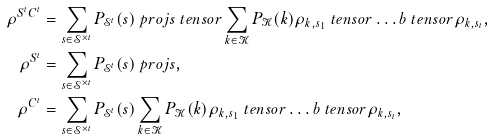<formula> <loc_0><loc_0><loc_500><loc_500>\rho ^ { S ^ { t } C ^ { t } } & = \sum _ { s \in \mathcal { S } ^ { \times t } } P _ { \mathcal { S } ^ { t } } ( s ) \ p r o j { s } \ t e n s o r \sum _ { k \in \mathcal { K } } P _ { \mathcal { K } } ( k ) \rho _ { k , s _ { 1 } } \ t e n s o r \dots b \ t e n s o r \rho _ { k , s _ { t } } , \\ \rho ^ { S ^ { t } } & = \sum _ { s \in \mathcal { S } ^ { \times t } } P _ { \mathcal { S } ^ { t } } ( s ) \ p r o j { s } , \\ \rho ^ { C ^ { t } } & = \sum _ { s \in \mathcal { S } ^ { \times t } } P _ { \mathcal { S } ^ { t } } ( s ) \sum _ { k \in \mathcal { K } } P _ { \mathcal { K } } ( k ) \rho _ { k , s _ { 1 } } \ t e n s o r \dots b \ t e n s o r \rho _ { k , s _ { t } } ,</formula> 